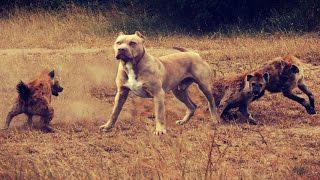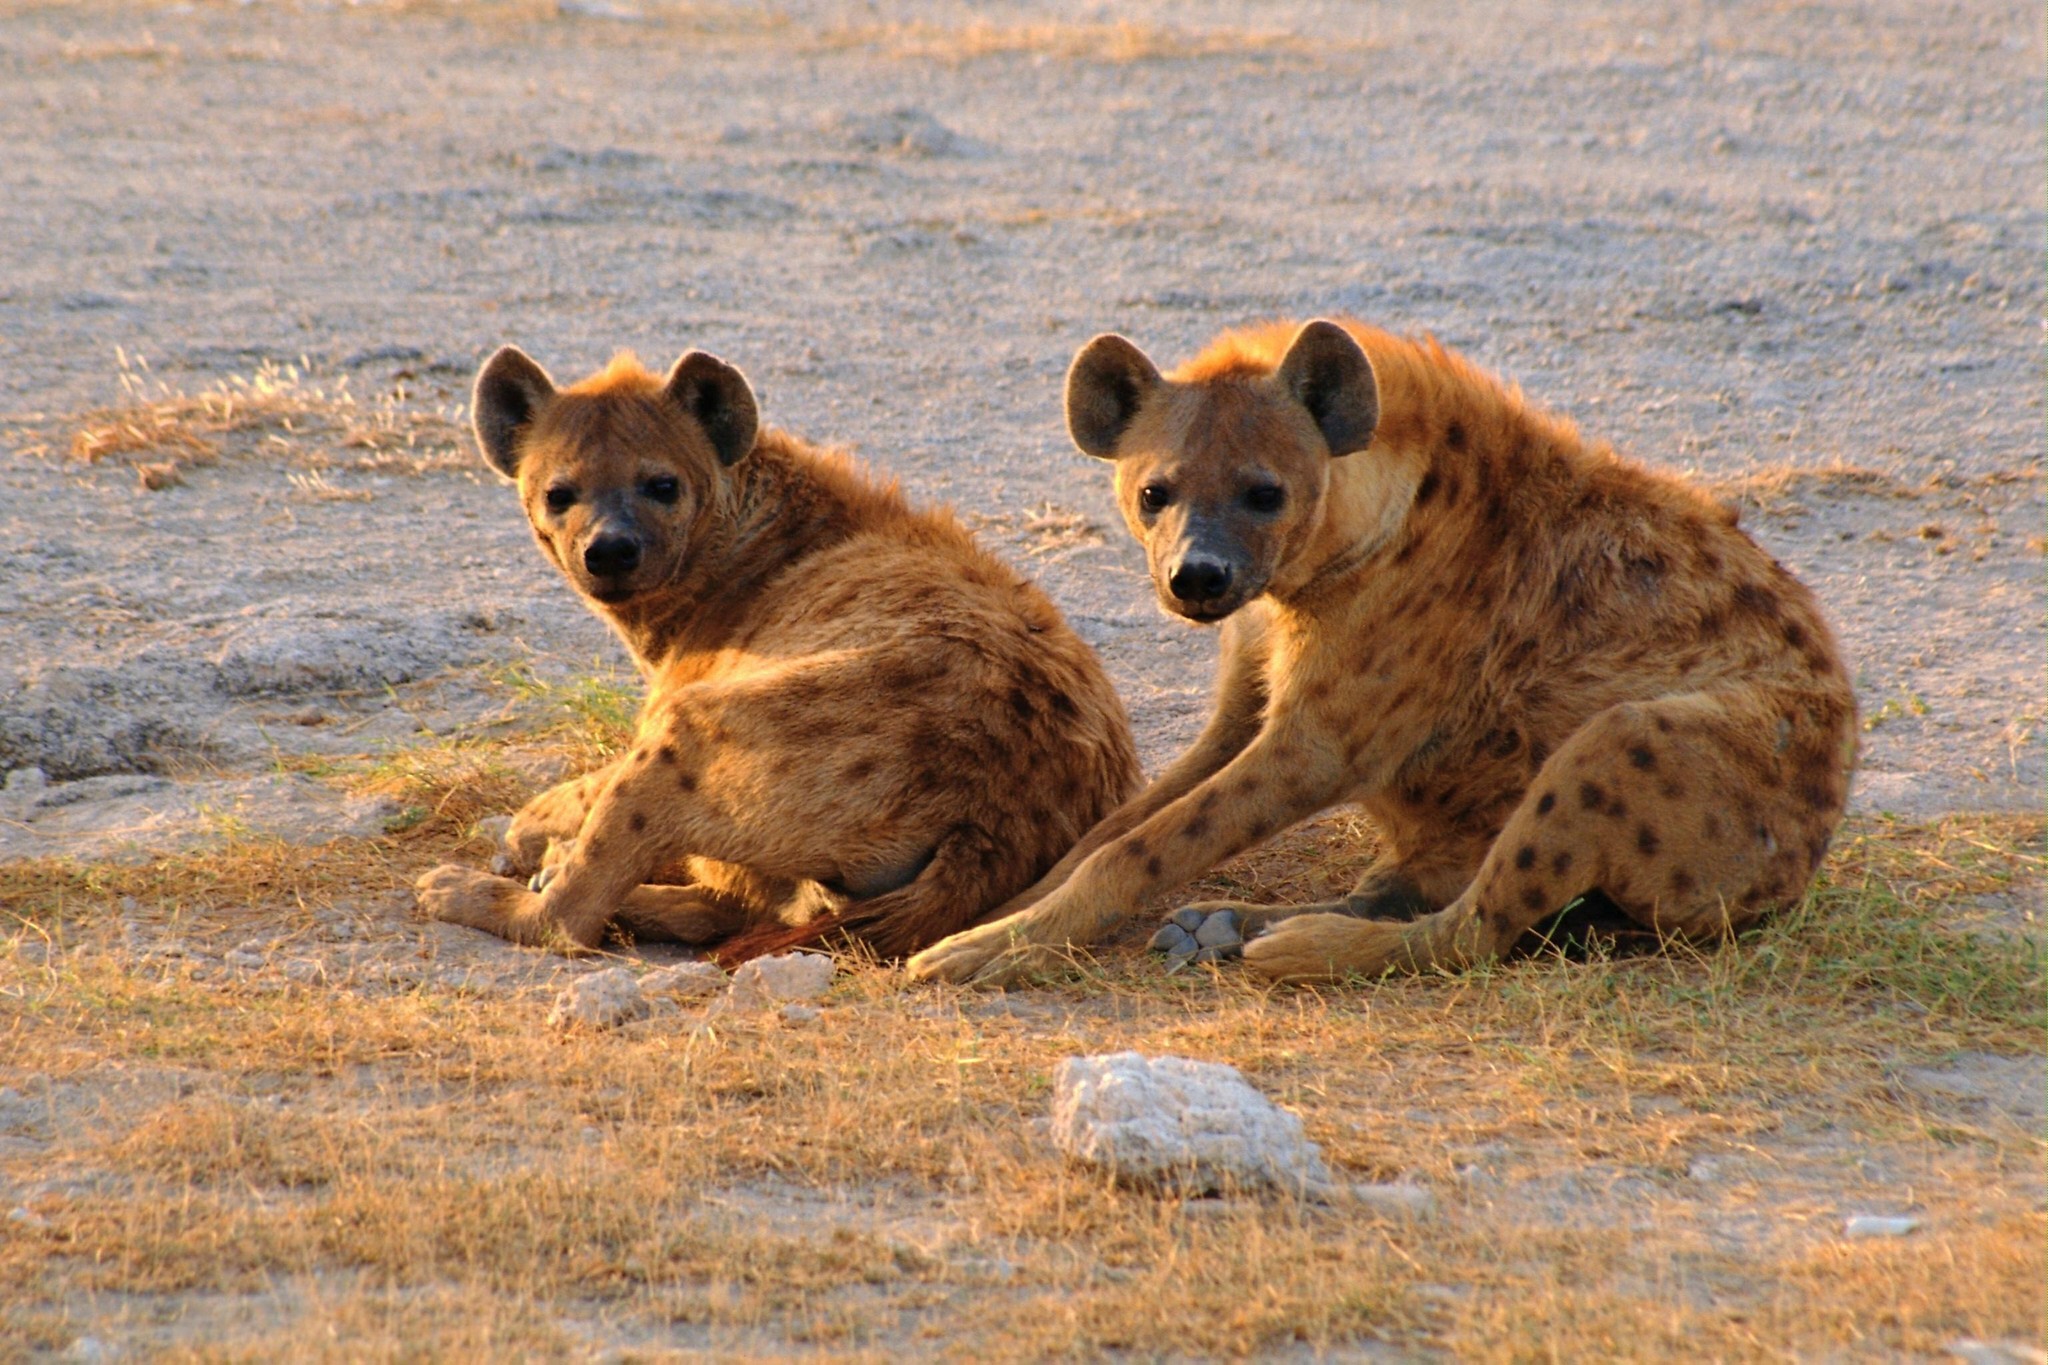The first image is the image on the left, the second image is the image on the right. Assess this claim about the two images: "There is no more than one hyena in the right image.". Correct or not? Answer yes or no. No. The first image is the image on the left, the second image is the image on the right. Analyze the images presented: Is the assertion "The target of the hyenas appears to still be alive in both images." valid? Answer yes or no. No. 